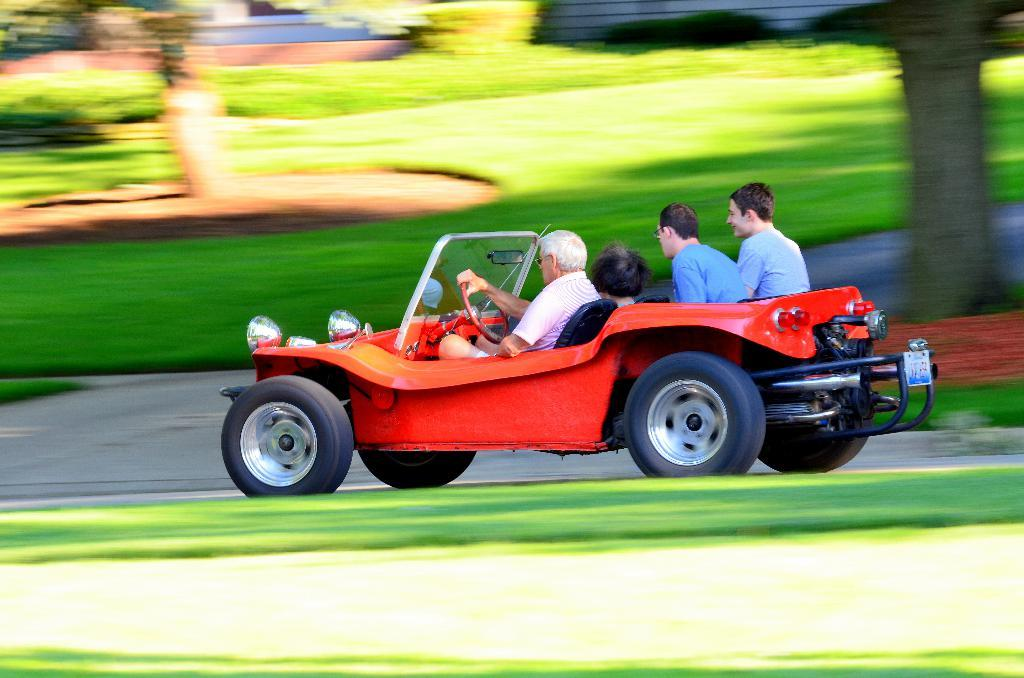What color is the car in the image? The car in the image is red. How many people are inside the car? Four people are sitting in the car. What can be seen in the background of the image? There are blurred trees in the background of the image. Where is the table located in the image? There is no table present in the image. Is the father of the people in the car visible in the image? The provided facts do not mention a father or any family relationships, so it cannot be determined if the father is present in the image. 